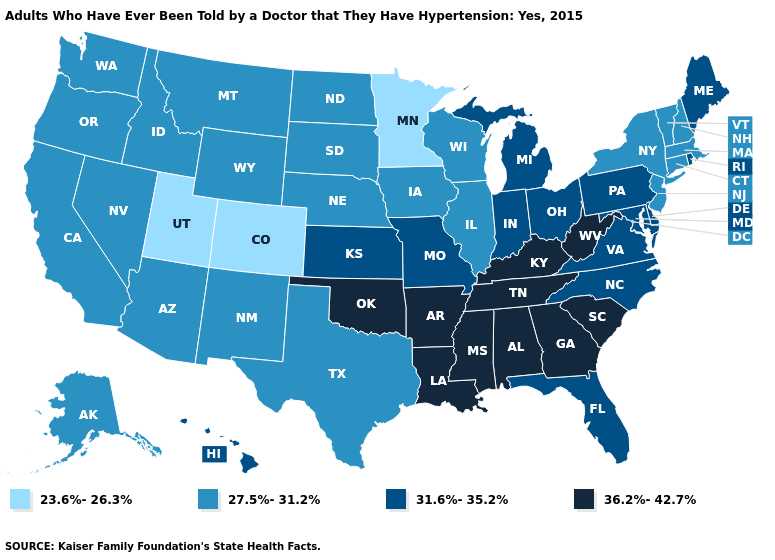Does Montana have the lowest value in the USA?
Give a very brief answer. No. What is the lowest value in the Northeast?
Answer briefly. 27.5%-31.2%. Among the states that border Maine , which have the lowest value?
Give a very brief answer. New Hampshire. What is the highest value in the USA?
Be succinct. 36.2%-42.7%. What is the value of Wisconsin?
Short answer required. 27.5%-31.2%. How many symbols are there in the legend?
Short answer required. 4. What is the value of South Carolina?
Keep it brief. 36.2%-42.7%. What is the value of Maryland?
Be succinct. 31.6%-35.2%. What is the lowest value in the USA?
Be succinct. 23.6%-26.3%. What is the value of Alabama?
Give a very brief answer. 36.2%-42.7%. What is the highest value in states that border North Dakota?
Quick response, please. 27.5%-31.2%. Name the states that have a value in the range 36.2%-42.7%?
Answer briefly. Alabama, Arkansas, Georgia, Kentucky, Louisiana, Mississippi, Oklahoma, South Carolina, Tennessee, West Virginia. What is the lowest value in the USA?
Answer briefly. 23.6%-26.3%. What is the value of Maryland?
Keep it brief. 31.6%-35.2%. What is the lowest value in the USA?
Concise answer only. 23.6%-26.3%. 